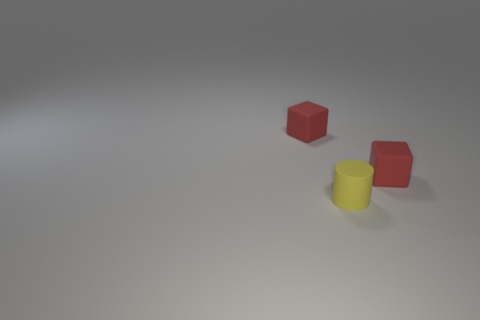Subtract all gray cylinders. Subtract all red spheres. How many cylinders are left? 1 Add 1 shiny spheres. How many objects exist? 4 Subtract all cylinders. How many objects are left? 2 Add 3 big yellow rubber objects. How many big yellow rubber objects exist? 3 Subtract 0 gray spheres. How many objects are left? 3 Subtract all tiny cylinders. Subtract all red matte objects. How many objects are left? 0 Add 2 tiny things. How many tiny things are left? 5 